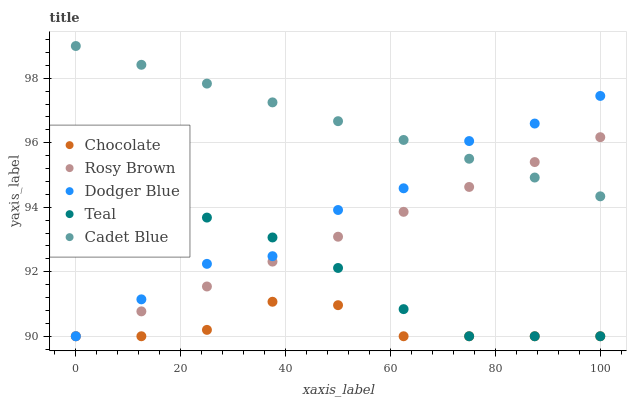Does Chocolate have the minimum area under the curve?
Answer yes or no. Yes. Does Cadet Blue have the maximum area under the curve?
Answer yes or no. Yes. Does Rosy Brown have the minimum area under the curve?
Answer yes or no. No. Does Rosy Brown have the maximum area under the curve?
Answer yes or no. No. Is Rosy Brown the smoothest?
Answer yes or no. Yes. Is Dodger Blue the roughest?
Answer yes or no. Yes. Is Dodger Blue the smoothest?
Answer yes or no. No. Is Rosy Brown the roughest?
Answer yes or no. No. Does Rosy Brown have the lowest value?
Answer yes or no. Yes. Does Cadet Blue have the highest value?
Answer yes or no. Yes. Does Rosy Brown have the highest value?
Answer yes or no. No. Is Chocolate less than Cadet Blue?
Answer yes or no. Yes. Is Cadet Blue greater than Teal?
Answer yes or no. Yes. Does Teal intersect Rosy Brown?
Answer yes or no. Yes. Is Teal less than Rosy Brown?
Answer yes or no. No. Is Teal greater than Rosy Brown?
Answer yes or no. No. Does Chocolate intersect Cadet Blue?
Answer yes or no. No. 